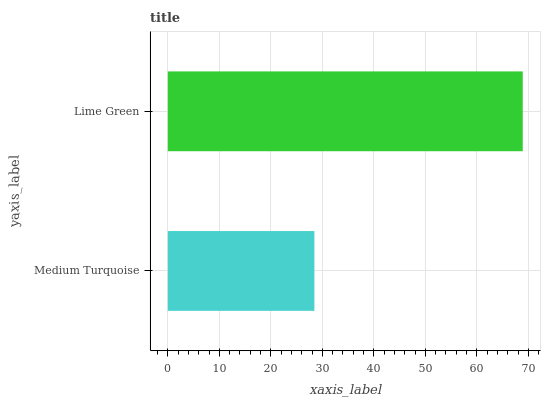Is Medium Turquoise the minimum?
Answer yes or no. Yes. Is Lime Green the maximum?
Answer yes or no. Yes. Is Lime Green the minimum?
Answer yes or no. No. Is Lime Green greater than Medium Turquoise?
Answer yes or no. Yes. Is Medium Turquoise less than Lime Green?
Answer yes or no. Yes. Is Medium Turquoise greater than Lime Green?
Answer yes or no. No. Is Lime Green less than Medium Turquoise?
Answer yes or no. No. Is Lime Green the high median?
Answer yes or no. Yes. Is Medium Turquoise the low median?
Answer yes or no. Yes. Is Medium Turquoise the high median?
Answer yes or no. No. Is Lime Green the low median?
Answer yes or no. No. 